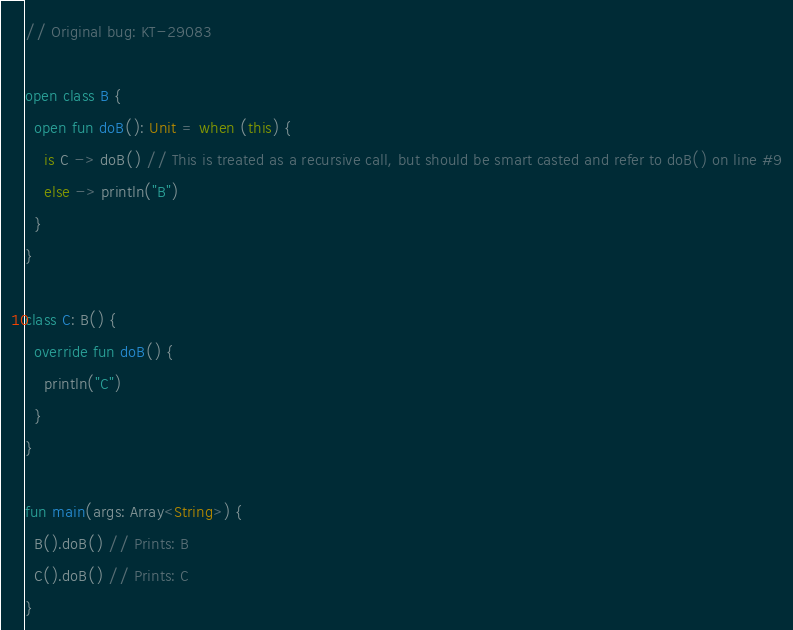Convert code to text. <code><loc_0><loc_0><loc_500><loc_500><_Kotlin_>// Original bug: KT-29083

open class B {
  open fun doB(): Unit = when (this) {
    is C -> doB() // This is treated as a recursive call, but should be smart casted and refer to doB() on line #9
    else -> println("B")
  }
}

class C: B() {
  override fun doB() {
    println("C")
  }
}

fun main(args: Array<String>) {
  B().doB() // Prints: B
  C().doB() // Prints: C
}
</code> 